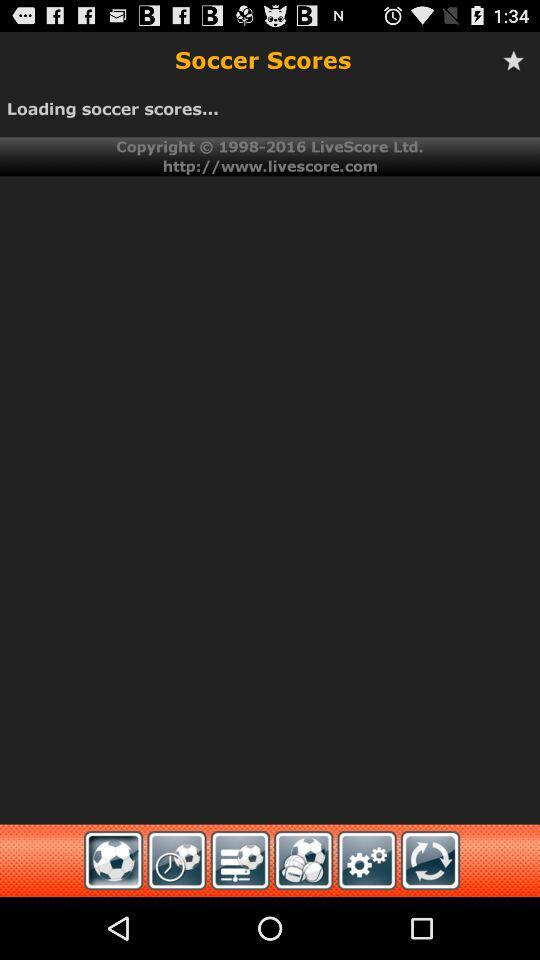What is the copyright year? The copyright years are from 1998 to 2016. 